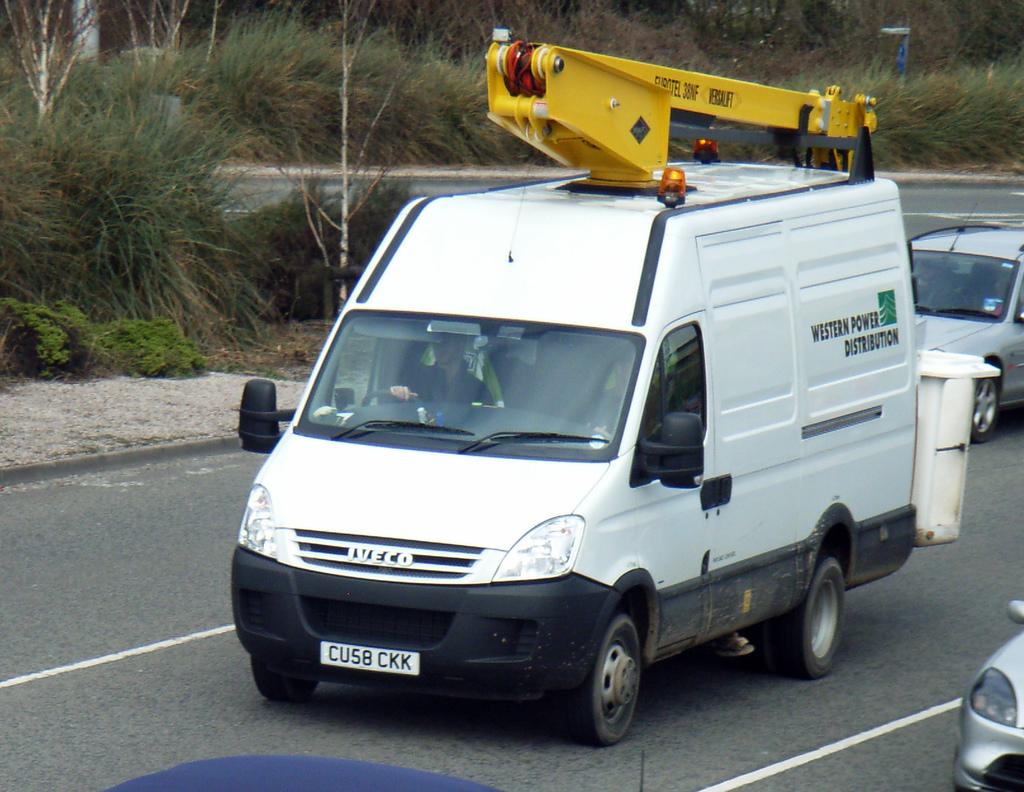What is the lisencse number?
Your answer should be very brief. Cu58 ckk. 